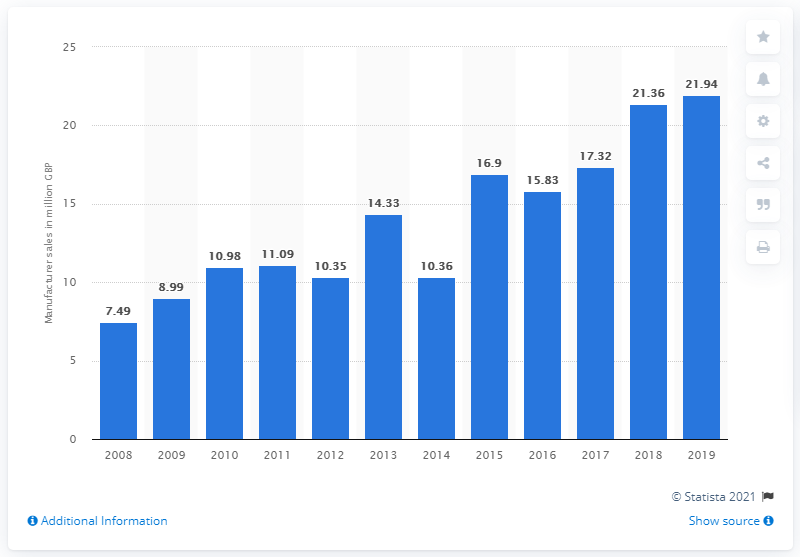Point out several critical features in this image. In 2019, the sales of semiconductor LEDs in the UK totaled 21.94 million units. 